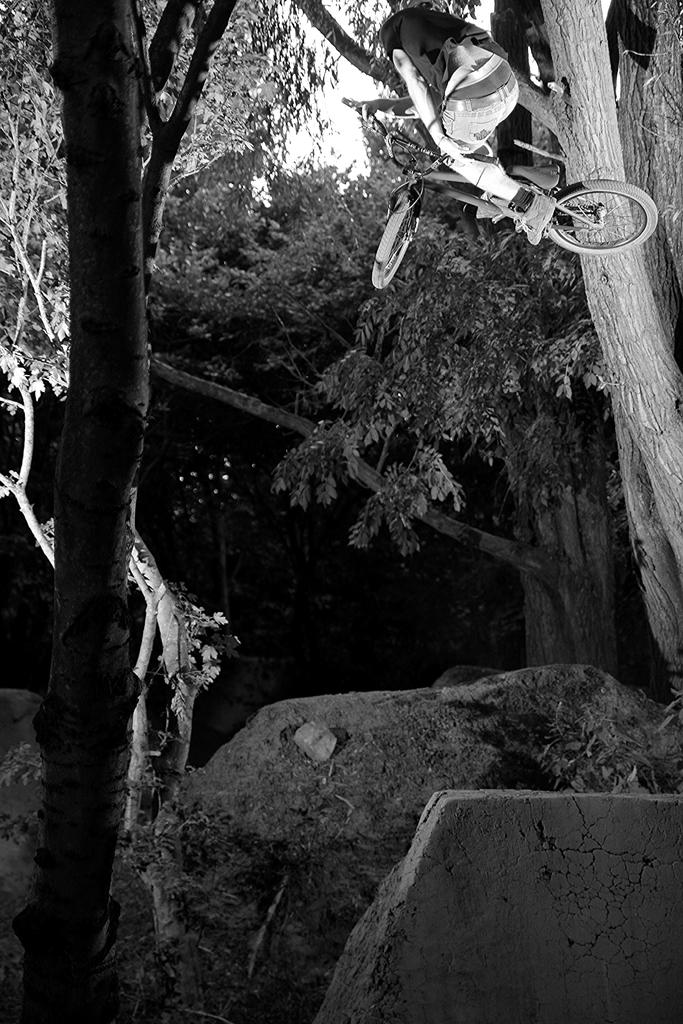What type of vegetation can be seen in the image? There are many trees and plants in the image. Can you describe the person in the image? The person in the image is riding a bicycle while in the air. What is the color scheme of the image? The image is in black and white. What type of thread is being used to hold up the curtain in the image? There is no curtain present in the image, so it is not possible to determine what type of thread might be used to hold it up. 